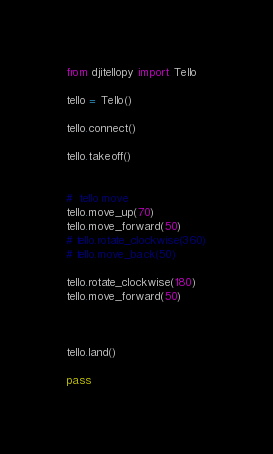<code> <loc_0><loc_0><loc_500><loc_500><_Python_>from djitellopy import Tello

tello = Tello()

tello.connect()

tello.takeoff()


#  tello move
tello.move_up(70)
tello.move_forward(50)
# tello.rotate_clockwise(360)
# tello.move_back(50)

tello.rotate_clockwise(180)
tello.move_forward(50)



tello.land()

pass</code> 